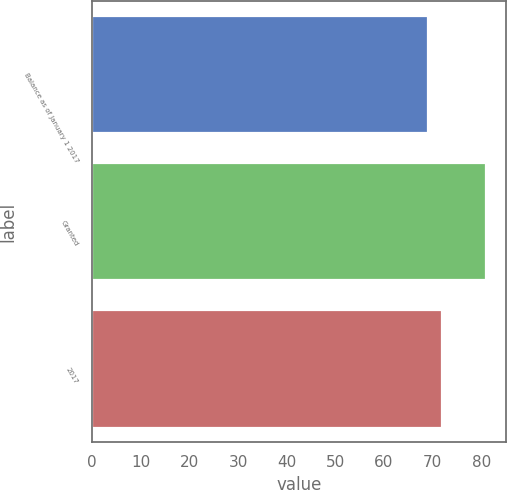Convert chart. <chart><loc_0><loc_0><loc_500><loc_500><bar_chart><fcel>Balance as of January 1 2017<fcel>Granted<fcel>2017<nl><fcel>69<fcel>81<fcel>72<nl></chart> 